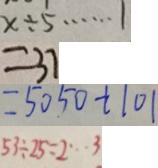<formula> <loc_0><loc_0><loc_500><loc_500>x \div 5 \cdots 1 
 = 3 7 
 = 5 0 5 0 + 1 0 1 
 5 3 \div 2 5 = 2 \cdots 3</formula> 